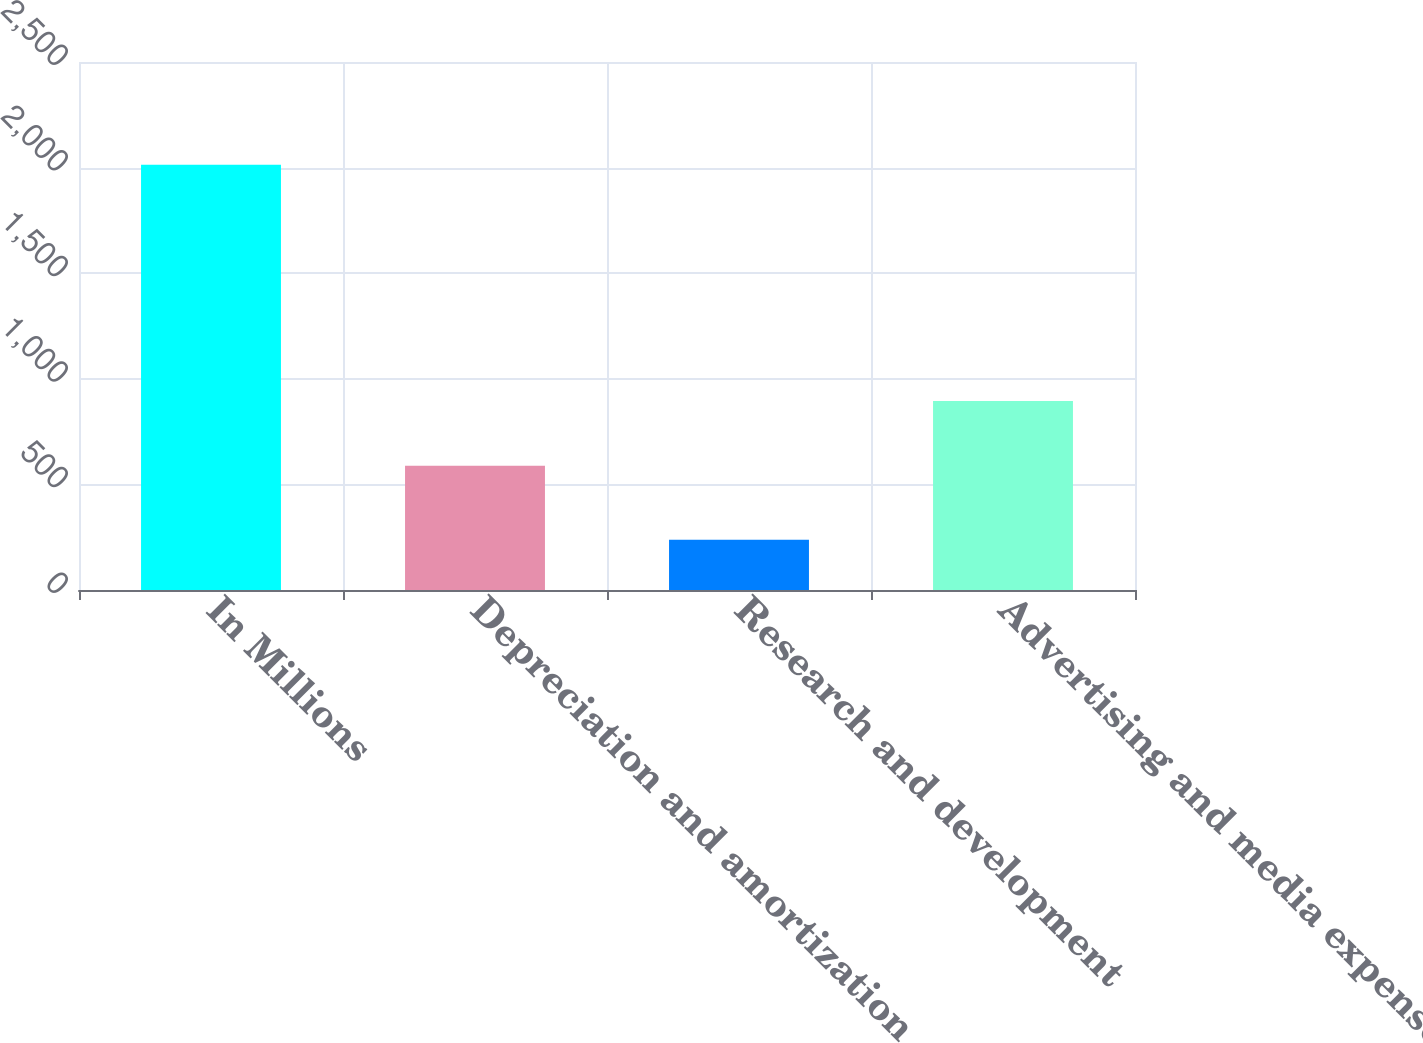Convert chart. <chart><loc_0><loc_0><loc_500><loc_500><bar_chart><fcel>In Millions<fcel>Depreciation and amortization<fcel>Research and development<fcel>Advertising and media expense<nl><fcel>2013<fcel>588<fcel>237.9<fcel>895<nl></chart> 